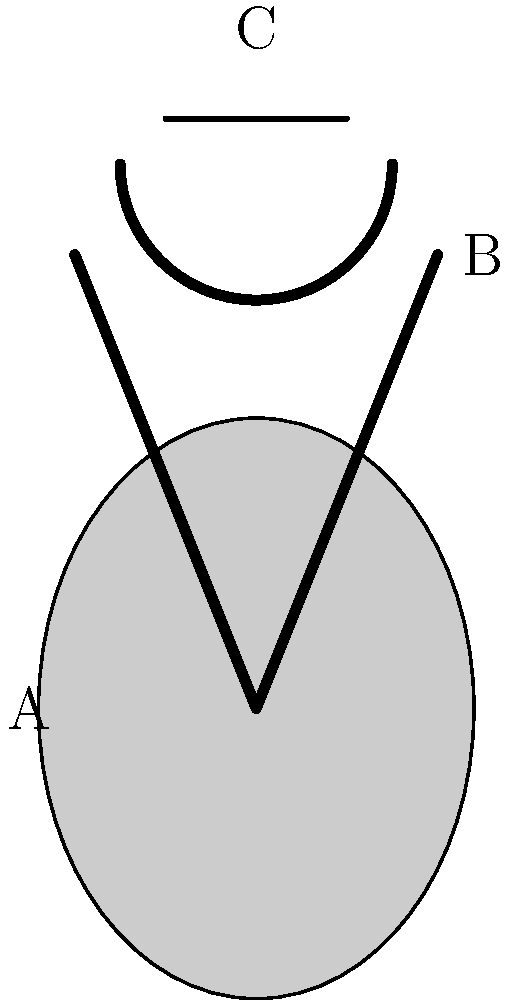Based on the visual characteristics of the medieval armor and weapons shown in the image, which item is most likely to be from the earliest time period, and approximately when would it have been used? To answer this question, we need to analyze the three items shown in the image and consider their historical context:

1. Item A: This appears to be a kite shield, characterized by its elongated teardrop shape. Kite shields were commonly used from the 10th to 12th centuries, particularly during the Norman period and the First Crusade.

2. Item B: This represents a straight, double-edged sword typical of the High Middle Ages. Such swords were widely used from the 11th to 13th centuries, evolving from earlier Viking-style swords.

3. Item C: This depicts a great helm or heaume, a type of helmet that fully enclosed the head. Great helms became popular in the late 12th century and were widely used throughout the 13th century.

Among these items, the kite shield (Item A) is likely to be from the earliest time period. Kite shields were introduced earlier than the great helm and were already in use before the straight, double-edged swords of the High Middle Ages became prevalent.

Kite shields were most commonly used from around 1000 AD to 1150 AD, although their use continued into the late 12th century in some areas. They were gradually phased out in favor of heater shields as plate armor became more common.

Therefore, the kite shield (Item A) is most likely to be from the earliest time period, dating approximately to the 11th century or early 12th century.
Answer: Item A (kite shield), circa 11th century 